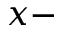<formula> <loc_0><loc_0><loc_500><loc_500>x -</formula> 